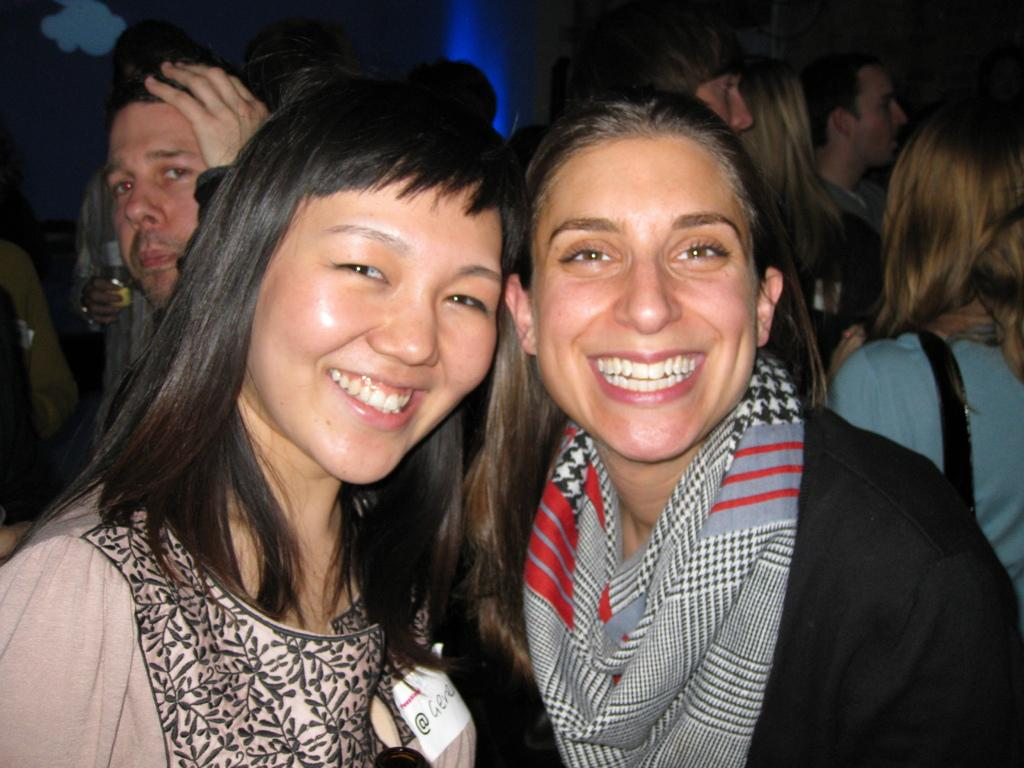How many women are in the image? There are two women standing in the middle of the image. What are the women doing in the image? The women are smiling. Are there any other people in the image besides the two women? Yes, there are people standing behind the women. What are some of the people holding in the image? Some of the people are holding glasses. What type of pleasure is the woman on the left experiencing in the image? There is no indication of pleasure in the image; the women are simply smiling. Is there a birthday celebration happening in the image? There is no information about a birthday celebration in the image. 